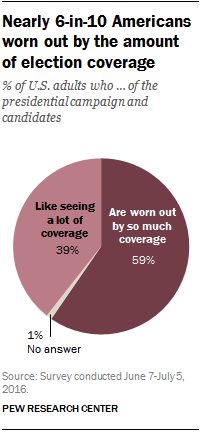Identify some key points in this picture. Approximately 39% of U.S. adults enjoy seeing extensive coverage of the presidential campaign and candidates. The ratio of the second largest segment to the sum of the smallest and largest segment is approximately 0.555555556. 